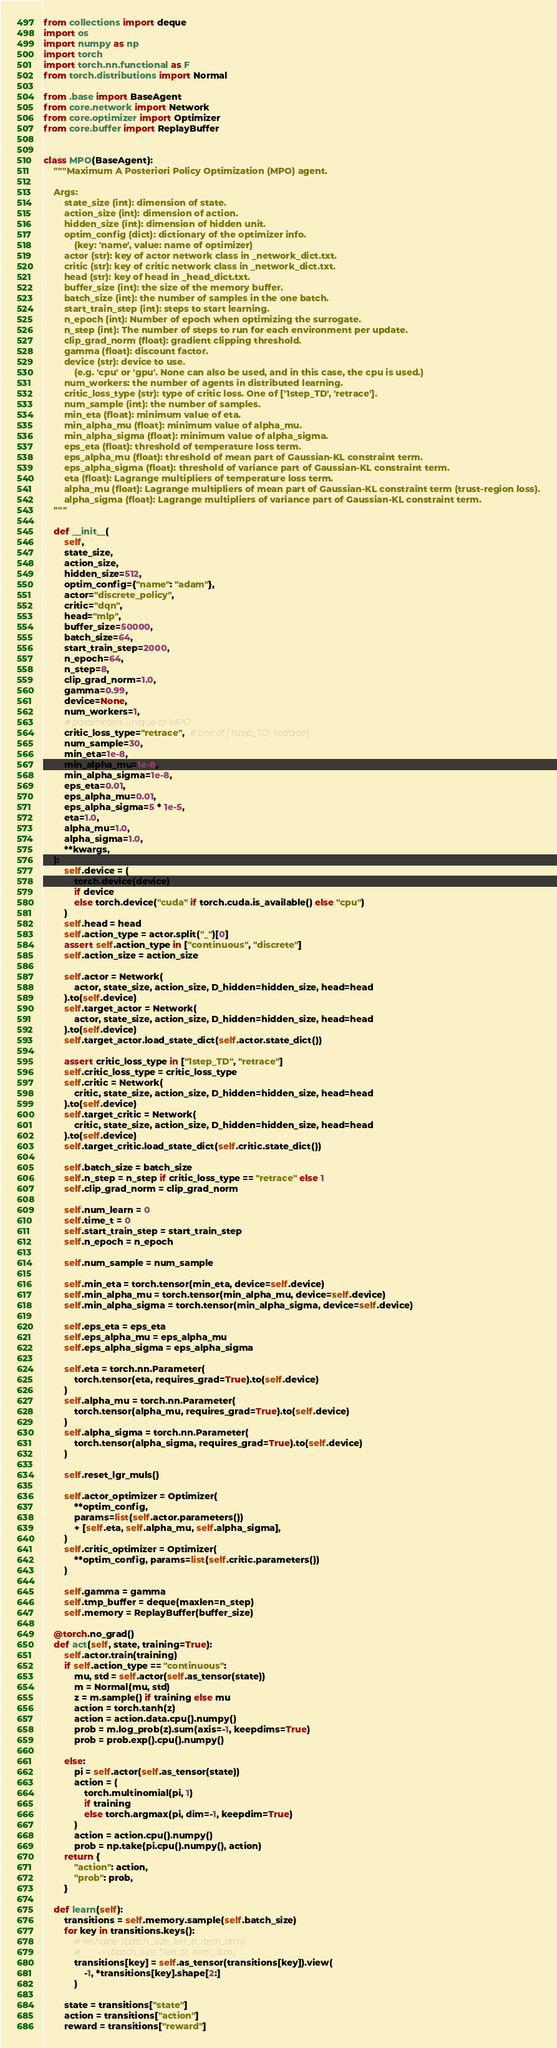Convert code to text. <code><loc_0><loc_0><loc_500><loc_500><_Python_>from collections import deque
import os
import numpy as np
import torch
import torch.nn.functional as F
from torch.distributions import Normal

from .base import BaseAgent
from core.network import Network
from core.optimizer import Optimizer
from core.buffer import ReplayBuffer


class MPO(BaseAgent):
    """Maximum A Posteriori Policy Optimization (MPO) agent.

    Args:
        state_size (int): dimension of state.
        action_size (int): dimension of action.
        hidden_size (int): dimension of hidden unit.
        optim_config (dict): dictionary of the optimizer info.
            (key: 'name', value: name of optimizer)
        actor (str): key of actor network class in _network_dict.txt.
        critic (str): key of critic network class in _network_dict.txt.
        head (str): key of head in _head_dict.txt.
        buffer_size (int): the size of the memory buffer.
        batch_size (int): the number of samples in the one batch.
        start_train_step (int): steps to start learning.
        n_epoch (int): Number of epoch when optimizing the surrogate.
        n_step (int): The number of steps to run for each environment per update.
        clip_grad_norm (float): gradient clipping threshold.
        gamma (float): discount factor.
        device (str): device to use.
            (e.g. 'cpu' or 'gpu'. None can also be used, and in this case, the cpu is used.)
        num_workers: the number of agents in distributed learning.
        critic_loss_type (str): type of critic loss. One of ['1step_TD', 'retrace'].
        num_sample (int): the number of samples.
        min_eta (float): minimum value of eta.
        min_alpha_mu (float): minimum value of alpha_mu.
        min_alpha_sigma (float): minimum value of alpha_sigma.
        eps_eta (float): threshold of temperature loss term.
        eps_alpha_mu (float): threshold of mean part of Gaussian-KL constraint term.
        eps_alpha_sigma (float): threshold of variance part of Gaussian-KL constraint term.
        eta (float): Lagrange multipliers of temperature loss term.
        alpha_mu (float): Lagrange multipliers of mean part of Gaussian-KL constraint term (trust-region loss).
        alpha_sigma (float): Lagrange multipliers of variance part of Gaussian-KL constraint term.
    """

    def __init__(
        self,
        state_size,
        action_size,
        hidden_size=512,
        optim_config={"name": "adam"},
        actor="discrete_policy",
        critic="dqn",
        head="mlp",
        buffer_size=50000,
        batch_size=64,
        start_train_step=2000,
        n_epoch=64,
        n_step=8,
        clip_grad_norm=1.0,
        gamma=0.99,
        device=None,
        num_workers=1,
        # parameters unique to MPO
        critic_loss_type="retrace",  # one of ['1step_TD', 'retrace']
        num_sample=30,
        min_eta=1e-8,
        min_alpha_mu=1e-8,
        min_alpha_sigma=1e-8,
        eps_eta=0.01,
        eps_alpha_mu=0.01,
        eps_alpha_sigma=5 * 1e-5,
        eta=1.0,
        alpha_mu=1.0,
        alpha_sigma=1.0,
        **kwargs,
    ):
        self.device = (
            torch.device(device)
            if device
            else torch.device("cuda" if torch.cuda.is_available() else "cpu")
        )
        self.head = head
        self.action_type = actor.split("_")[0]
        assert self.action_type in ["continuous", "discrete"]
        self.action_size = action_size

        self.actor = Network(
            actor, state_size, action_size, D_hidden=hidden_size, head=head
        ).to(self.device)
        self.target_actor = Network(
            actor, state_size, action_size, D_hidden=hidden_size, head=head
        ).to(self.device)
        self.target_actor.load_state_dict(self.actor.state_dict())

        assert critic_loss_type in ["1step_TD", "retrace"]
        self.critic_loss_type = critic_loss_type
        self.critic = Network(
            critic, state_size, action_size, D_hidden=hidden_size, head=head
        ).to(self.device)
        self.target_critic = Network(
            critic, state_size, action_size, D_hidden=hidden_size, head=head
        ).to(self.device)
        self.target_critic.load_state_dict(self.critic.state_dict())

        self.batch_size = batch_size
        self.n_step = n_step if critic_loss_type == "retrace" else 1
        self.clip_grad_norm = clip_grad_norm

        self.num_learn = 0
        self.time_t = 0
        self.start_train_step = start_train_step
        self.n_epoch = n_epoch

        self.num_sample = num_sample

        self.min_eta = torch.tensor(min_eta, device=self.device)
        self.min_alpha_mu = torch.tensor(min_alpha_mu, device=self.device)
        self.min_alpha_sigma = torch.tensor(min_alpha_sigma, device=self.device)

        self.eps_eta = eps_eta
        self.eps_alpha_mu = eps_alpha_mu
        self.eps_alpha_sigma = eps_alpha_sigma

        self.eta = torch.nn.Parameter(
            torch.tensor(eta, requires_grad=True).to(self.device)
        )
        self.alpha_mu = torch.nn.Parameter(
            torch.tensor(alpha_mu, requires_grad=True).to(self.device)
        )
        self.alpha_sigma = torch.nn.Parameter(
            torch.tensor(alpha_sigma, requires_grad=True).to(self.device)
        )

        self.reset_lgr_muls()

        self.actor_optimizer = Optimizer(
            **optim_config,
            params=list(self.actor.parameters())
            + [self.eta, self.alpha_mu, self.alpha_sigma],
        )
        self.critic_optimizer = Optimizer(
            **optim_config, params=list(self.critic.parameters())
        )

        self.gamma = gamma
        self.tmp_buffer = deque(maxlen=n_step)
        self.memory = ReplayBuffer(buffer_size)

    @torch.no_grad()
    def act(self, state, training=True):
        self.actor.train(training)
        if self.action_type == "continuous":
            mu, std = self.actor(self.as_tensor(state))
            m = Normal(mu, std)
            z = m.sample() if training else mu
            action = torch.tanh(z)
            action = action.data.cpu().numpy()
            prob = m.log_prob(z).sum(axis=-1, keepdims=True)
            prob = prob.exp().cpu().numpy()

        else:
            pi = self.actor(self.as_tensor(state))
            action = (
                torch.multinomial(pi, 1)
                if training
                else torch.argmax(pi, dim=-1, keepdim=True)
            )
            action = action.cpu().numpy()
            prob = np.take(pi.cpu().numpy(), action)
        return {
            "action": action,
            "prob": prob,
        }

    def learn(self):
        transitions = self.memory.sample(self.batch_size)
        for key in transitions.keys():
            # reshape: (batch_size, len_tr, item_dim)
            #        -> (batch_size * len_tr, item_dim)
            transitions[key] = self.as_tensor(transitions[key]).view(
                -1, *transitions[key].shape[2:]
            )

        state = transitions["state"]
        action = transitions["action"]
        reward = transitions["reward"]</code> 